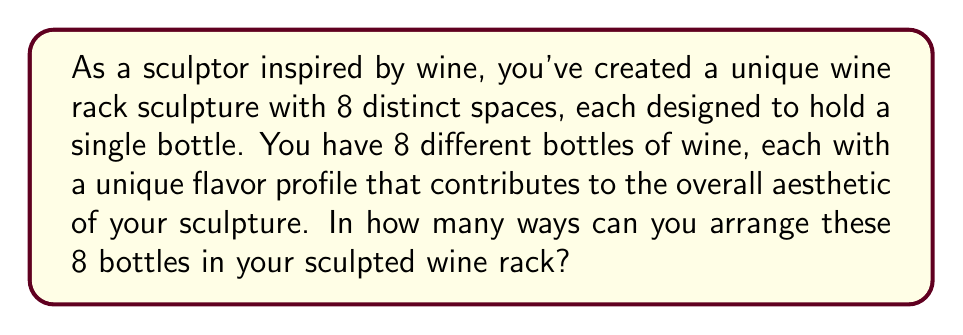Teach me how to tackle this problem. To solve this problem, we need to consider the following:

1. We have 8 distinct spaces in the wine rack sculpture.
2. We have 8 different bottles of wine.
3. Each bottle must be placed in one of the spaces.
4. The order of placement matters, as it affects the overall aesthetic of the sculpture.

This scenario is a perfect example of a permutation problem. We are arranging all 8 bottles in 8 spaces, where the order matters.

The formula for permutations of n distinct objects is:

$$ P(n) = n! $$

Where $n!$ represents the factorial of n.

In this case, $n = 8$, so we calculate:

$$ P(8) = 8! $$

$$ 8! = 8 \times 7 \times 6 \times 5 \times 4 \times 3 \times 2 \times 1 $$

Let's break this down step by step:

$$ 8 \times 7 = 56 $$
$$ 56 \times 6 = 336 $$
$$ 336 \times 5 = 1,680 $$
$$ 1,680 \times 4 = 6,720 $$
$$ 6,720 \times 3 = 20,160 $$
$$ 20,160 \times 2 = 40,320 $$
$$ 40,320 \times 1 = 40,320 $$

Therefore, the total number of ways to arrange the 8 bottles in the sculpted wine rack is 40,320.
Answer: $$ 40,320 $$ 